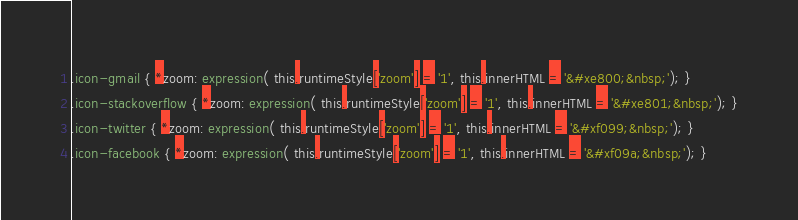Convert code to text. <code><loc_0><loc_0><loc_500><loc_500><_CSS_>
.icon-gmail { *zoom: expression( this.runtimeStyle['zoom'] = '1', this.innerHTML = '&#xe800;&nbsp;'); }
.icon-stackoverflow { *zoom: expression( this.runtimeStyle['zoom'] = '1', this.innerHTML = '&#xe801;&nbsp;'); }
.icon-twitter { *zoom: expression( this.runtimeStyle['zoom'] = '1', this.innerHTML = '&#xf099;&nbsp;'); }
.icon-facebook { *zoom: expression( this.runtimeStyle['zoom'] = '1', this.innerHTML = '&#xf09a;&nbsp;'); }</code> 